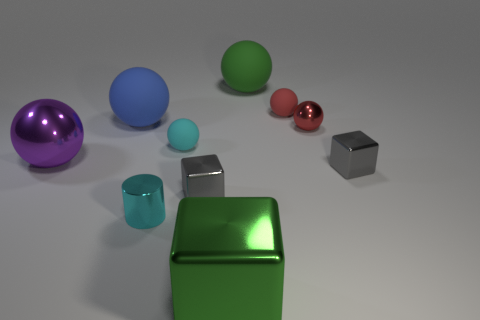How many other objects are the same size as the purple thing?
Offer a terse response. 3. Do the red object to the left of the small red shiny sphere and the small cyan shiny thing have the same shape?
Offer a terse response. No. Is the number of small red matte objects that are in front of the blue object greater than the number of tiny gray objects?
Give a very brief answer. No. The cube that is both left of the small red matte thing and behind the cyan metallic cylinder is made of what material?
Give a very brief answer. Metal. Is there anything else that has the same shape as the small red rubber thing?
Give a very brief answer. Yes. How many large objects are in front of the green rubber object and behind the big green cube?
Give a very brief answer. 2. What material is the big block?
Your response must be concise. Metal. Are there the same number of metallic spheres behind the small red rubber sphere and large purple shiny cylinders?
Make the answer very short. Yes. How many big gray things have the same shape as the blue thing?
Your response must be concise. 0. Is the shape of the purple metallic thing the same as the small red shiny object?
Give a very brief answer. Yes. 